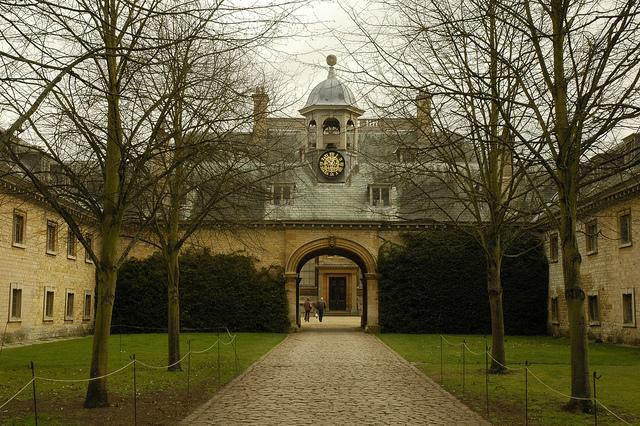What does this setting most resemble? college campus 